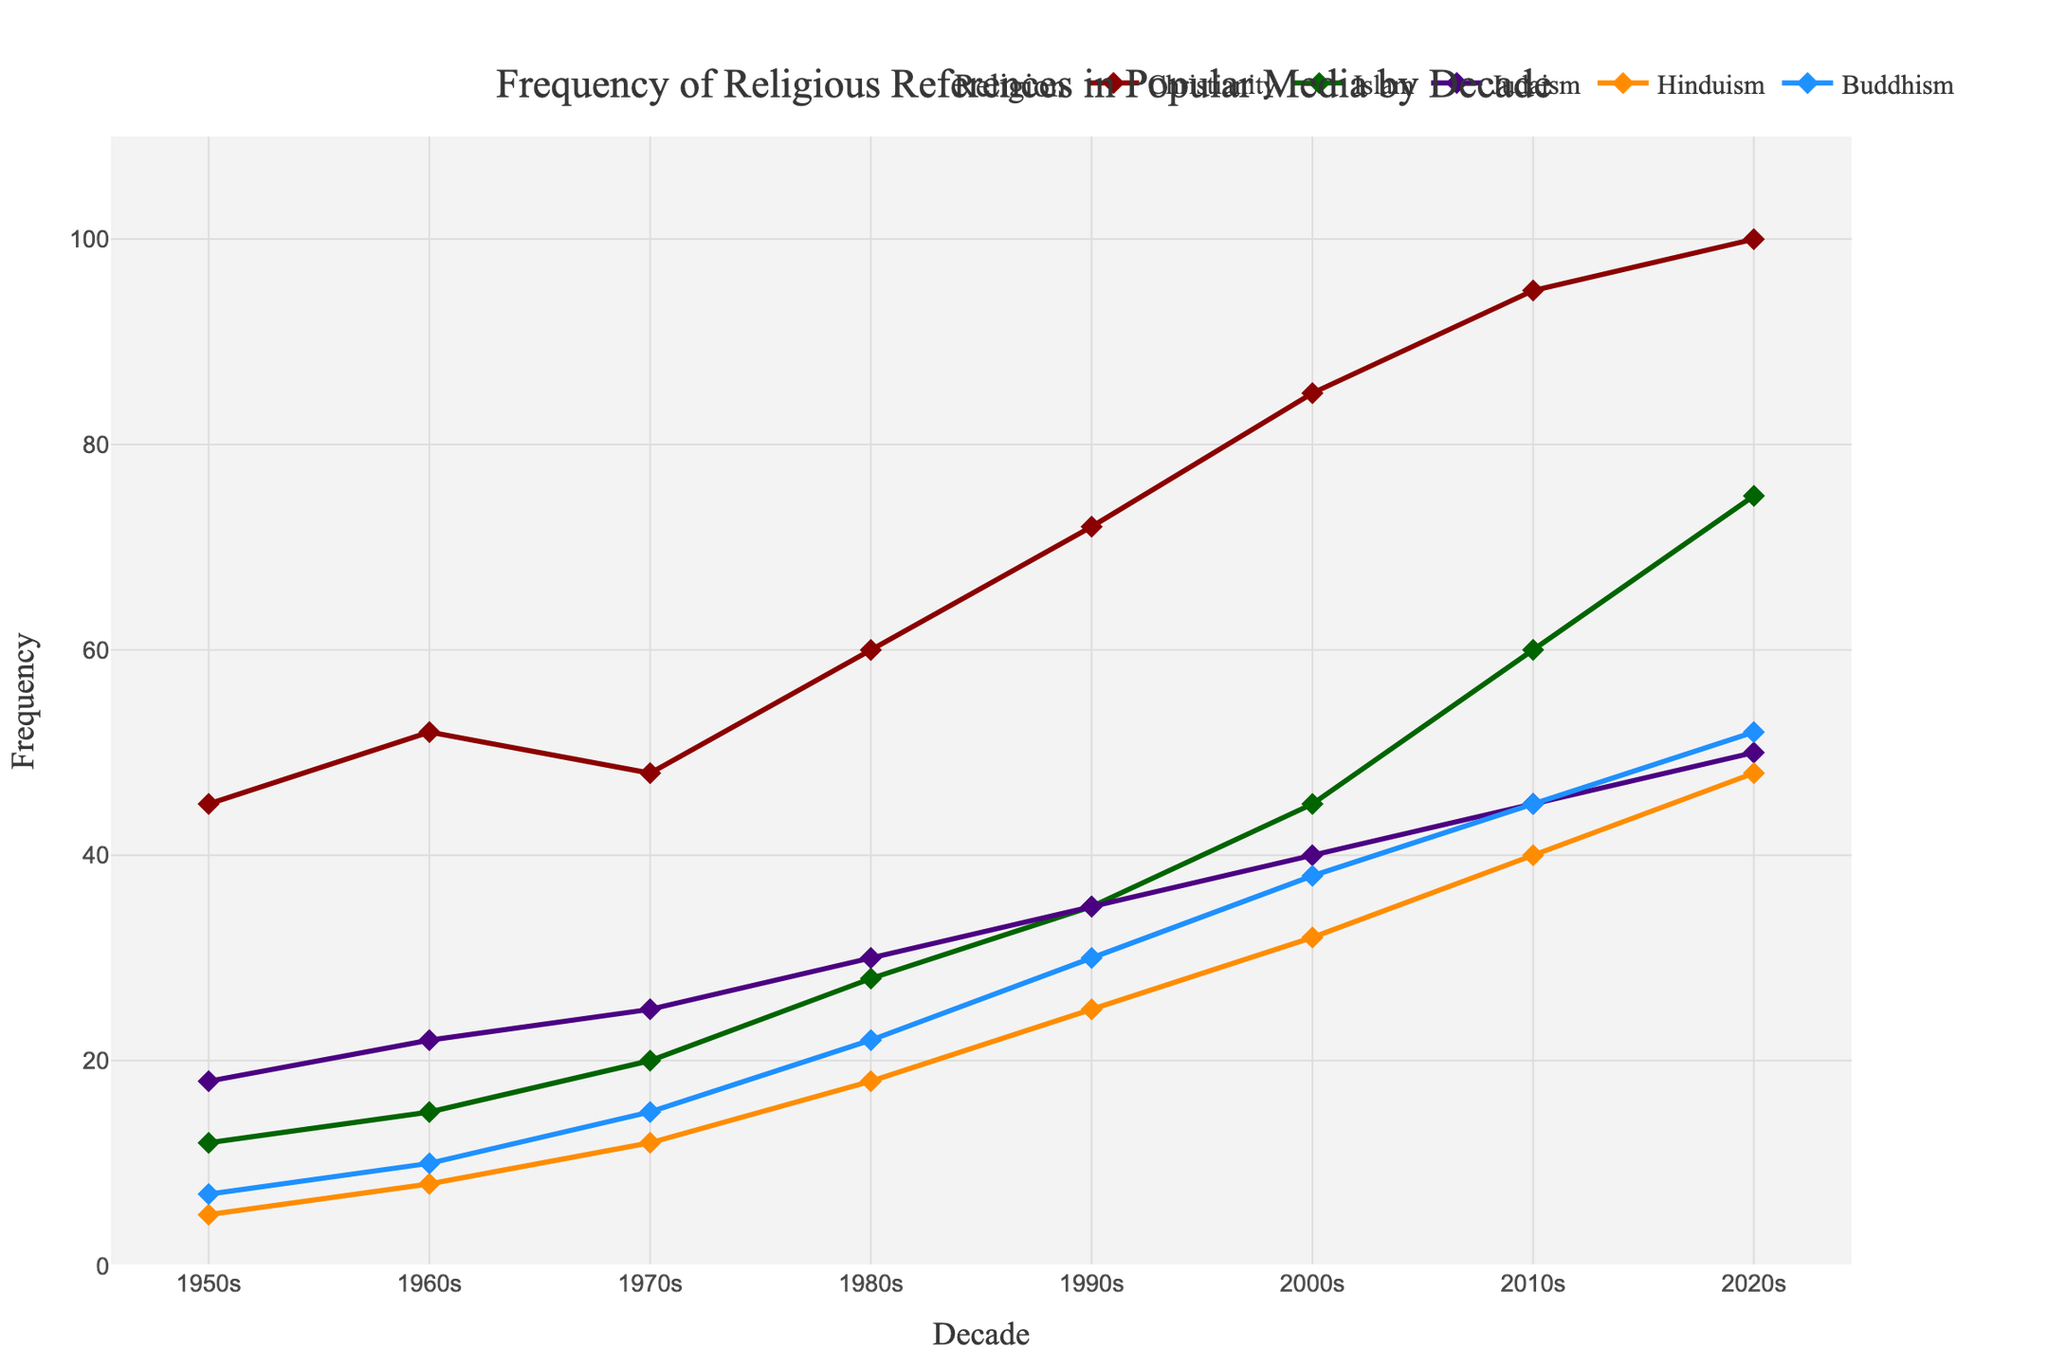What is the frequency of Christian references in the 1980s? The figure shows the frequency of religious references by decade. Locate the point for Christianity on the y-axis corresponding to the 1980s.
Answer: 60 Which decade had the highest frequency of Buddhist references? Look for the highest point on the line representing Buddhism across different decades.
Answer: 2020s How does the frequency of Jewish references in the 1950s compare to that in the 2000s? Locate the frequency values for Judaism in the 1950s and the 2000s, then compare them directly.
Answer: The 2000s have a higher frequency than the 1950s What is the total frequency of Hindu references from the 1950s to the 1980s? Sum the frequencies of Hindu references for the decades 1950s, 1960s, 1970s, and 1980s: 5 + 8 + 12 + 18 = 43
Answer: 43 By how much did the frequency of Islamic references increase from the 1960s to the 2020s? Subtract the frequency value of Islam in the 1960s from that in the 2020s: 75 - 15 = 60
Answer: 60 Which religious reference had the least frequency in the 1970s and what was its value? Identify the lowest point among the religions in the 1970s.
Answer: Hinduism with a value of 12 Compare the growth trend of Christianity and Buddhism from the 2000s to the 2020s. Analyze and compare the slopes of the lines representing Christianity and Buddhism between these decades. Both lines show upward trends but Christianity's growth is from 85 to 100, while Buddhism's growth is from 38 to 52.
Answer: Both increased, Christianity by 15 and Buddhism by 14 What is the average frequency of references for Judaism across all decades? Sum the frequencies for Judaism across all decades and divide by the number of decades: (18 + 22 + 25 + 30 + 35 + 40 + 45 + 50) / 8 = 33.125
Answer: 33.125 